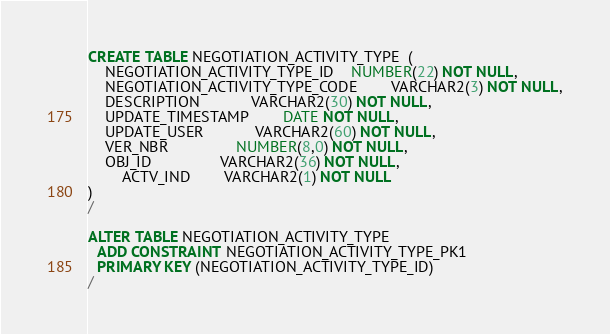Convert code to text. <code><loc_0><loc_0><loc_500><loc_500><_SQL_>CREATE TABLE NEGOTIATION_ACTIVITY_TYPE  ( 
    NEGOTIATION_ACTIVITY_TYPE_ID	NUMBER(22) NOT NULL,
	NEGOTIATION_ACTIVITY_TYPE_CODE	    VARCHAR2(3) NOT NULL,
	DESCRIPTION          	VARCHAR2(30) NOT NULL,
	UPDATE_TIMESTAMP     	DATE NOT NULL,
	UPDATE_USER          	VARCHAR2(60) NOT NULL,
	VER_NBR              	NUMBER(8,0) NOT NULL,
	OBJ_ID               	VARCHAR2(36) NOT NULL,
        ACTV_IND		VARCHAR2(1) NOT NULL
)
/

ALTER TABLE NEGOTIATION_ACTIVITY_TYPE
  ADD CONSTRAINT NEGOTIATION_ACTIVITY_TYPE_PK1
  PRIMARY KEY (NEGOTIATION_ACTIVITY_TYPE_ID)
/
</code> 